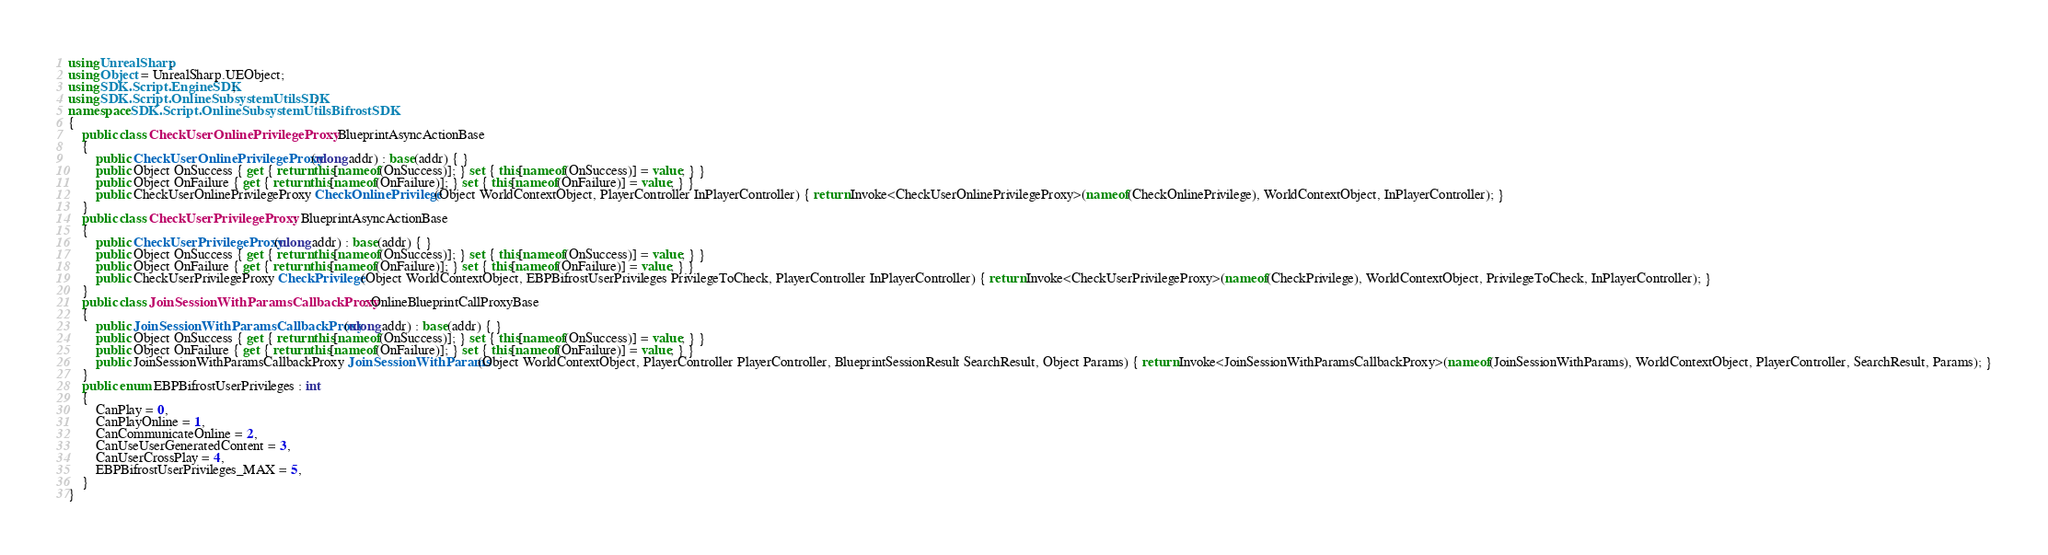Convert code to text. <code><loc_0><loc_0><loc_500><loc_500><_C#_>using UnrealSharp;
using Object = UnrealSharp.UEObject;
using SDK.Script.EngineSDK;
using SDK.Script.OnlineSubsystemUtilsSDK;
namespace SDK.Script.OnlineSubsystemUtilsBifrostSDK
{
    public class CheckUserOnlinePrivilegeProxy : BlueprintAsyncActionBase
    {
        public CheckUserOnlinePrivilegeProxy(ulong addr) : base(addr) { }
        public Object OnSuccess { get { return this[nameof(OnSuccess)]; } set { this[nameof(OnSuccess)] = value; } }
        public Object OnFailure { get { return this[nameof(OnFailure)]; } set { this[nameof(OnFailure)] = value; } }
        public CheckUserOnlinePrivilegeProxy CheckOnlinePrivilege(Object WorldContextObject, PlayerController InPlayerController) { return Invoke<CheckUserOnlinePrivilegeProxy>(nameof(CheckOnlinePrivilege), WorldContextObject, InPlayerController); }
    }
    public class CheckUserPrivilegeProxy : BlueprintAsyncActionBase
    {
        public CheckUserPrivilegeProxy(ulong addr) : base(addr) { }
        public Object OnSuccess { get { return this[nameof(OnSuccess)]; } set { this[nameof(OnSuccess)] = value; } }
        public Object OnFailure { get { return this[nameof(OnFailure)]; } set { this[nameof(OnFailure)] = value; } }
        public CheckUserPrivilegeProxy CheckPrivilege(Object WorldContextObject, EBPBifrostUserPrivileges PrivilegeToCheck, PlayerController InPlayerController) { return Invoke<CheckUserPrivilegeProxy>(nameof(CheckPrivilege), WorldContextObject, PrivilegeToCheck, InPlayerController); }
    }
    public class JoinSessionWithParamsCallbackProxy : OnlineBlueprintCallProxyBase
    {
        public JoinSessionWithParamsCallbackProxy(ulong addr) : base(addr) { }
        public Object OnSuccess { get { return this[nameof(OnSuccess)]; } set { this[nameof(OnSuccess)] = value; } }
        public Object OnFailure { get { return this[nameof(OnFailure)]; } set { this[nameof(OnFailure)] = value; } }
        public JoinSessionWithParamsCallbackProxy JoinSessionWithParams(Object WorldContextObject, PlayerController PlayerController, BlueprintSessionResult SearchResult, Object Params) { return Invoke<JoinSessionWithParamsCallbackProxy>(nameof(JoinSessionWithParams), WorldContextObject, PlayerController, SearchResult, Params); }
    }
    public enum EBPBifrostUserPrivileges : int
    {
        CanPlay = 0,
        CanPlayOnline = 1,
        CanCommunicateOnline = 2,
        CanUseUserGeneratedContent = 3,
        CanUserCrossPlay = 4,
        EBPBifrostUserPrivileges_MAX = 5,
    }
}
</code> 